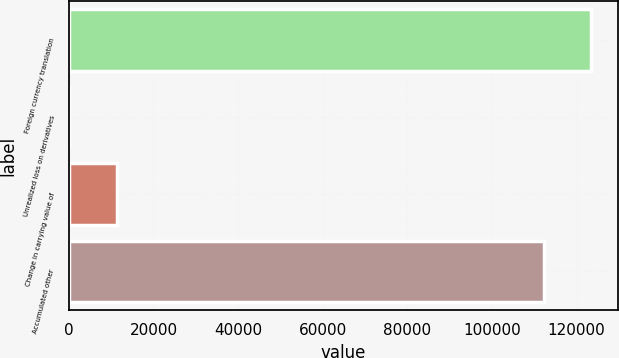Convert chart. <chart><loc_0><loc_0><loc_500><loc_500><bar_chart><fcel>Foreign currency translation<fcel>Unrealized loss on derivatives<fcel>Change in carrying value of<fcel>Accumulated other<nl><fcel>123496<fcel>84<fcel>11316.7<fcel>112263<nl></chart> 